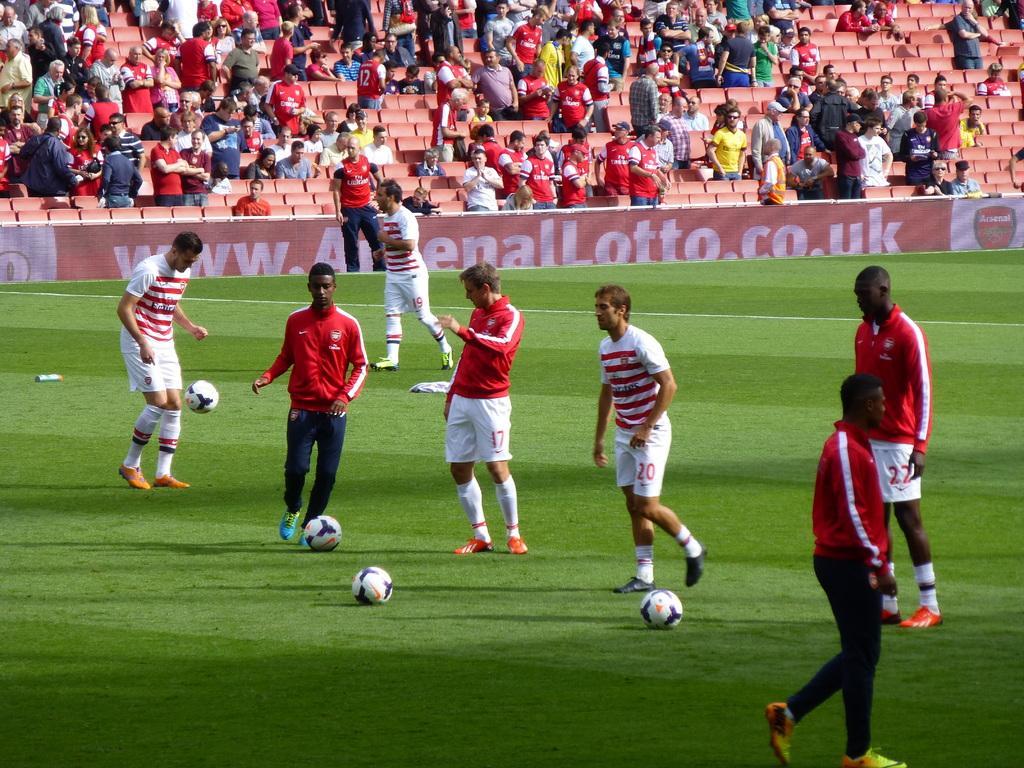How would you summarize this image in a sentence or two? This is a picture taken in the outdoor. There are group of people playing on the ground with balls. Behind the people there are group of people some are sitting and some are standing. 